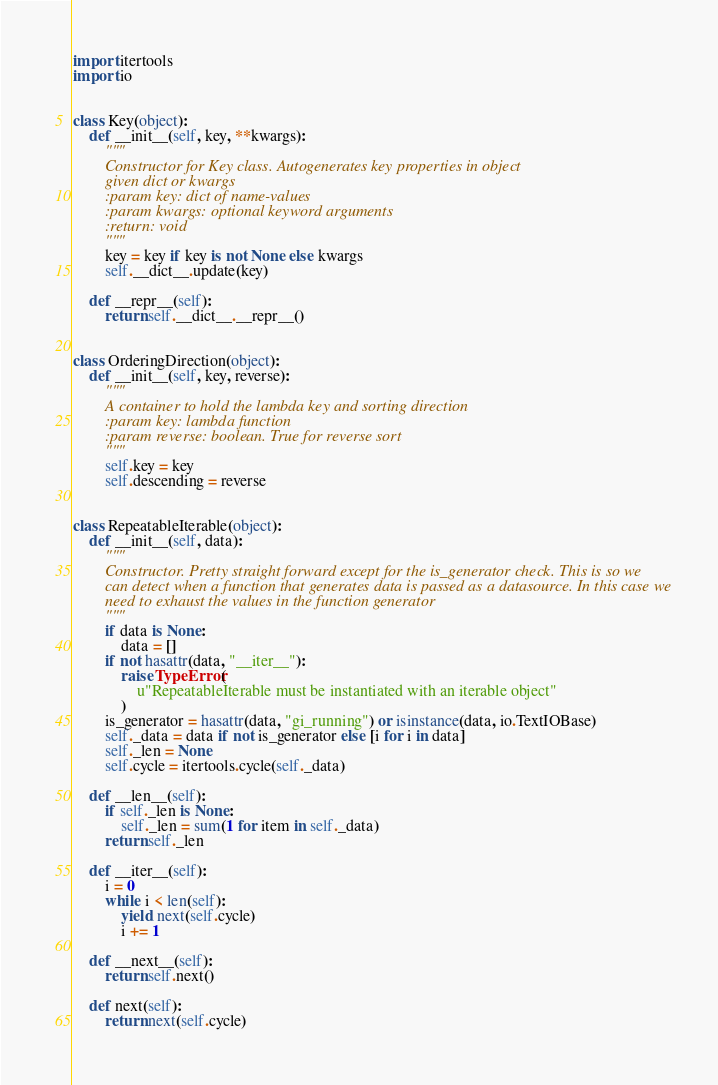Convert code to text. <code><loc_0><loc_0><loc_500><loc_500><_Python_>import itertools
import io


class Key(object):
    def __init__(self, key, **kwargs):
        """
        Constructor for Key class. Autogenerates key properties in object
        given dict or kwargs
        :param key: dict of name-values
        :param kwargs: optional keyword arguments
        :return: void
        """
        key = key if key is not None else kwargs
        self.__dict__.update(key)

    def __repr__(self):
        return self.__dict__.__repr__()


class OrderingDirection(object):
    def __init__(self, key, reverse):
        """
        A container to hold the lambda key and sorting direction
        :param key: lambda function
        :param reverse: boolean. True for reverse sort
        """
        self.key = key
        self.descending = reverse


class RepeatableIterable(object):
    def __init__(self, data):
        """
        Constructor. Pretty straight forward except for the is_generator check. This is so we
        can detect when a function that generates data is passed as a datasource. In this case we
        need to exhaust the values in the function generator
        """
        if data is None:
            data = []
        if not hasattr(data, "__iter__"):
            raise TypeError(
                u"RepeatableIterable must be instantiated with an iterable object"
            )
        is_generator = hasattr(data, "gi_running") or isinstance(data, io.TextIOBase)
        self._data = data if not is_generator else [i for i in data]
        self._len = None
        self.cycle = itertools.cycle(self._data)

    def __len__(self):
        if self._len is None:
            self._len = sum(1 for item in self._data)
        return self._len

    def __iter__(self):
        i = 0
        while i < len(self):
            yield next(self.cycle)
            i += 1

    def __next__(self):
        return self.next()

    def next(self):
        return next(self.cycle)
</code> 